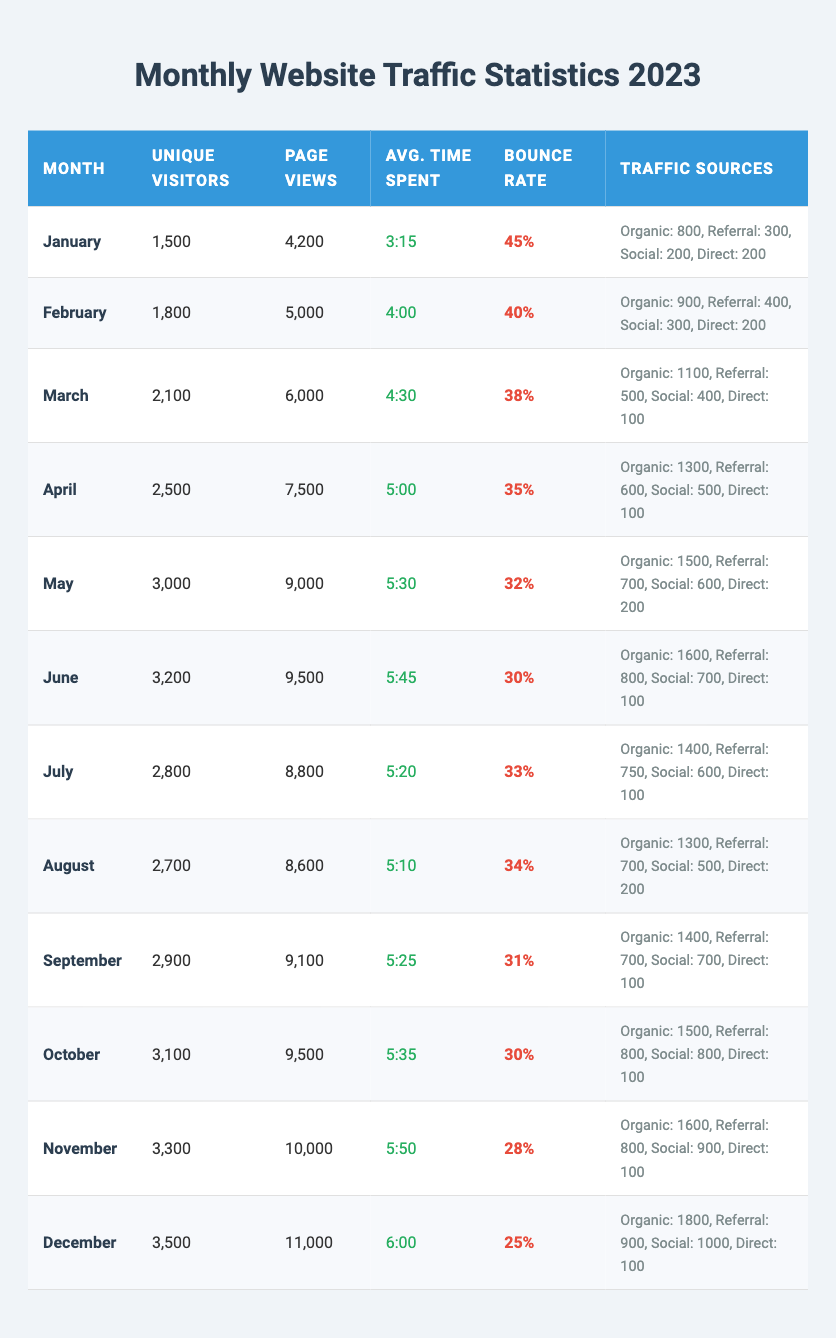What is the unique visitor count for June? In the table, search for the row corresponding to June, where the unique visitor count is stated. The unique visitors for June are 3,200.
Answer: 3200 What is the average time spent by visitors in December? Look for the month of December in the table and find the value under the "Avg. Time Spent" column. The average time spent in December is 6:00.
Answer: 6:00 Which month had the highest bounce rate? Check the "Bounce Rate" column for each month. December has the lowest bounce rate at 25%, while January has the highest at 45%.
Answer: January Calculate the total page views for the first half of the year (January to June). Sum the page views for each month from January to June: 4200 + 5000 + 6000 + 7500 + 9000 + 9500 = 41500.
Answer: 41500 What percentage of traffic in March came from organic sources? In March, the total traffic sources are 2,100 (unique visitors). The organic visitors are 1,100, so (1100/2100)*100 = 52.38%, rounding this gives approximately 52%.
Answer: 52% In which month did the blog achieve over 3,000 unique visitors for the first time? Traverse the "Unique Visitors" data from the start until you find the first month that crosses 3,000. This occurs in May with a total of 3,000 visitors.
Answer: May Which month had the highest number of page views, and how many were there? Determine the month with the highest value in the "Page Views" column. December has the most page views with 11,000.
Answer: December, 11000 Is the average time spent by visitors decreasing over the months? Examine the "Avg. Time Spent" data month by month and note the trend. From January (3:15) to December (6:00), the average time is actually increasing, not decreasing.
Answer: No What was the total number of unique visitors from July to December? Sum the unique visitors from July to December: 2800 + 2700 + 2900 + 3100 + 3300 + 3500 = 18,300.
Answer: 18300 Was the number of organic visitors in October greater than in March? Compare the organic visitor counts for October (1500) and March (1100). October has more organic visitors than March.
Answer: Yes How much did the bounce rate decrease from January to December? Subtract January's bounce rate (45%) from December's (25%): 45% - 25% = 20%. The bounce rate decreased by 20%.
Answer: 20% 